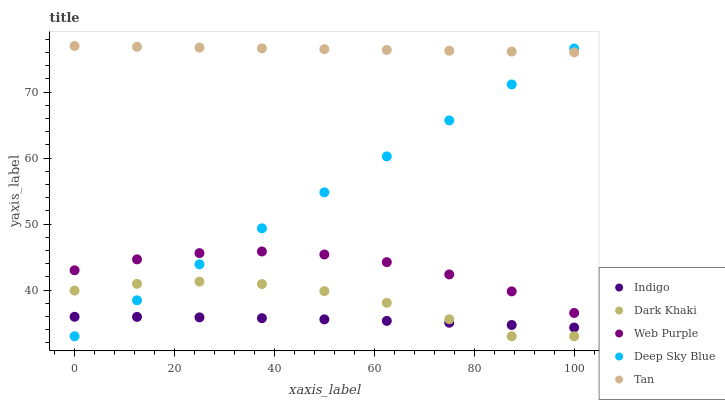Does Indigo have the minimum area under the curve?
Answer yes or no. Yes. Does Tan have the maximum area under the curve?
Answer yes or no. Yes. Does Web Purple have the minimum area under the curve?
Answer yes or no. No. Does Web Purple have the maximum area under the curve?
Answer yes or no. No. Is Deep Sky Blue the smoothest?
Answer yes or no. Yes. Is Dark Khaki the roughest?
Answer yes or no. Yes. Is Web Purple the smoothest?
Answer yes or no. No. Is Web Purple the roughest?
Answer yes or no. No. Does Dark Khaki have the lowest value?
Answer yes or no. Yes. Does Web Purple have the lowest value?
Answer yes or no. No. Does Tan have the highest value?
Answer yes or no. Yes. Does Web Purple have the highest value?
Answer yes or no. No. Is Indigo less than Web Purple?
Answer yes or no. Yes. Is Tan greater than Dark Khaki?
Answer yes or no. Yes. Does Indigo intersect Deep Sky Blue?
Answer yes or no. Yes. Is Indigo less than Deep Sky Blue?
Answer yes or no. No. Is Indigo greater than Deep Sky Blue?
Answer yes or no. No. Does Indigo intersect Web Purple?
Answer yes or no. No. 